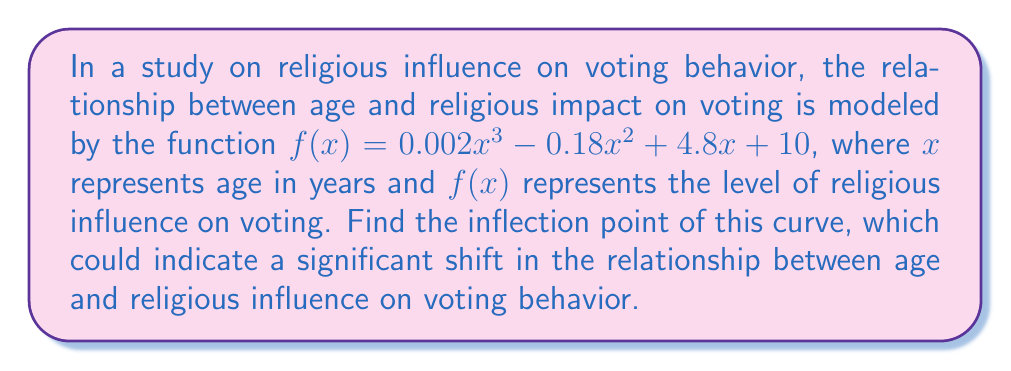Show me your answer to this math problem. To find the inflection point, we need to follow these steps:

1) The inflection point occurs where the second derivative of the function equals zero.

2) First, let's find the first derivative:
   $f'(x) = 0.006x^2 - 0.36x + 4.8$

3) Now, let's find the second derivative:
   $f''(x) = 0.012x - 0.36$

4) Set the second derivative equal to zero and solve for x:
   $0.012x - 0.36 = 0$
   $0.012x = 0.36$
   $x = 30$

5) To find the y-coordinate of the inflection point, we need to plug x = 30 into the original function:

   $f(30) = 0.002(30)^3 - 0.18(30)^2 + 4.8(30) + 10$
          $= 0.002(27000) - 0.18(900) + 144 + 10$
          $= 54 - 162 + 144 + 10$
          $= 46$

6) Therefore, the inflection point is (30, 46).

This point represents the age at which the rate of change in religious influence on voting behavior shifts, potentially indicating a significant transition in how age affects religious impact on voting.
Answer: (30, 46) 